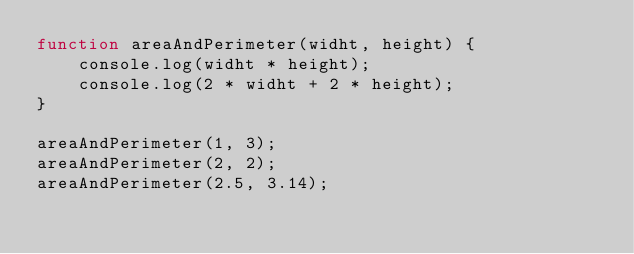<code> <loc_0><loc_0><loc_500><loc_500><_JavaScript_>function areaAndPerimeter(widht, height) {
    console.log(widht * height);
    console.log(2 * widht + 2 * height);
}

areaAndPerimeter(1, 3);
areaAndPerimeter(2, 2);
areaAndPerimeter(2.5, 3.14);</code> 